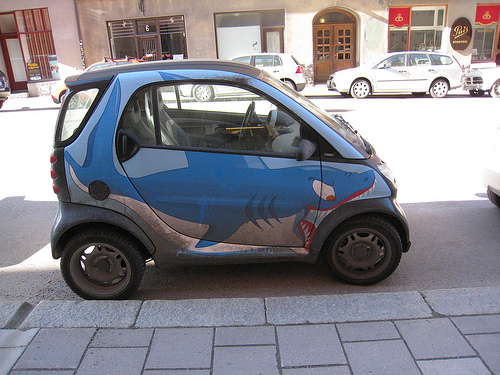<image>
Is the smart car under the bar pub? No. The smart car is not positioned under the bar pub. The vertical relationship between these objects is different. 